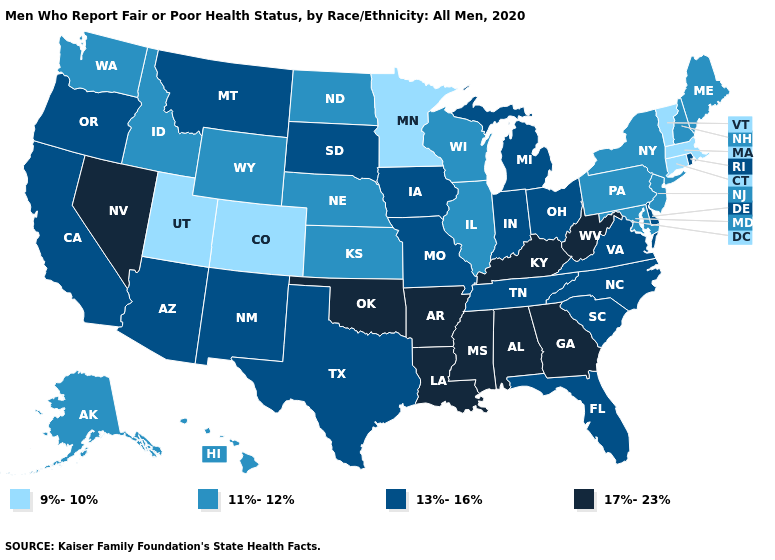How many symbols are there in the legend?
Answer briefly. 4. What is the value of Michigan?
Write a very short answer. 13%-16%. What is the value of South Dakota?
Give a very brief answer. 13%-16%. Name the states that have a value in the range 13%-16%?
Answer briefly. Arizona, California, Delaware, Florida, Indiana, Iowa, Michigan, Missouri, Montana, New Mexico, North Carolina, Ohio, Oregon, Rhode Island, South Carolina, South Dakota, Tennessee, Texas, Virginia. Name the states that have a value in the range 13%-16%?
Concise answer only. Arizona, California, Delaware, Florida, Indiana, Iowa, Michigan, Missouri, Montana, New Mexico, North Carolina, Ohio, Oregon, Rhode Island, South Carolina, South Dakota, Tennessee, Texas, Virginia. Name the states that have a value in the range 13%-16%?
Quick response, please. Arizona, California, Delaware, Florida, Indiana, Iowa, Michigan, Missouri, Montana, New Mexico, North Carolina, Ohio, Oregon, Rhode Island, South Carolina, South Dakota, Tennessee, Texas, Virginia. What is the highest value in states that border Maine?
Keep it brief. 11%-12%. Which states hav the highest value in the South?
Give a very brief answer. Alabama, Arkansas, Georgia, Kentucky, Louisiana, Mississippi, Oklahoma, West Virginia. Name the states that have a value in the range 13%-16%?
Give a very brief answer. Arizona, California, Delaware, Florida, Indiana, Iowa, Michigan, Missouri, Montana, New Mexico, North Carolina, Ohio, Oregon, Rhode Island, South Carolina, South Dakota, Tennessee, Texas, Virginia. What is the lowest value in states that border Arizona?
Keep it brief. 9%-10%. Which states hav the highest value in the West?
Answer briefly. Nevada. What is the value of New Mexico?
Answer briefly. 13%-16%. What is the highest value in the USA?
Answer briefly. 17%-23%. What is the value of New York?
Short answer required. 11%-12%. 